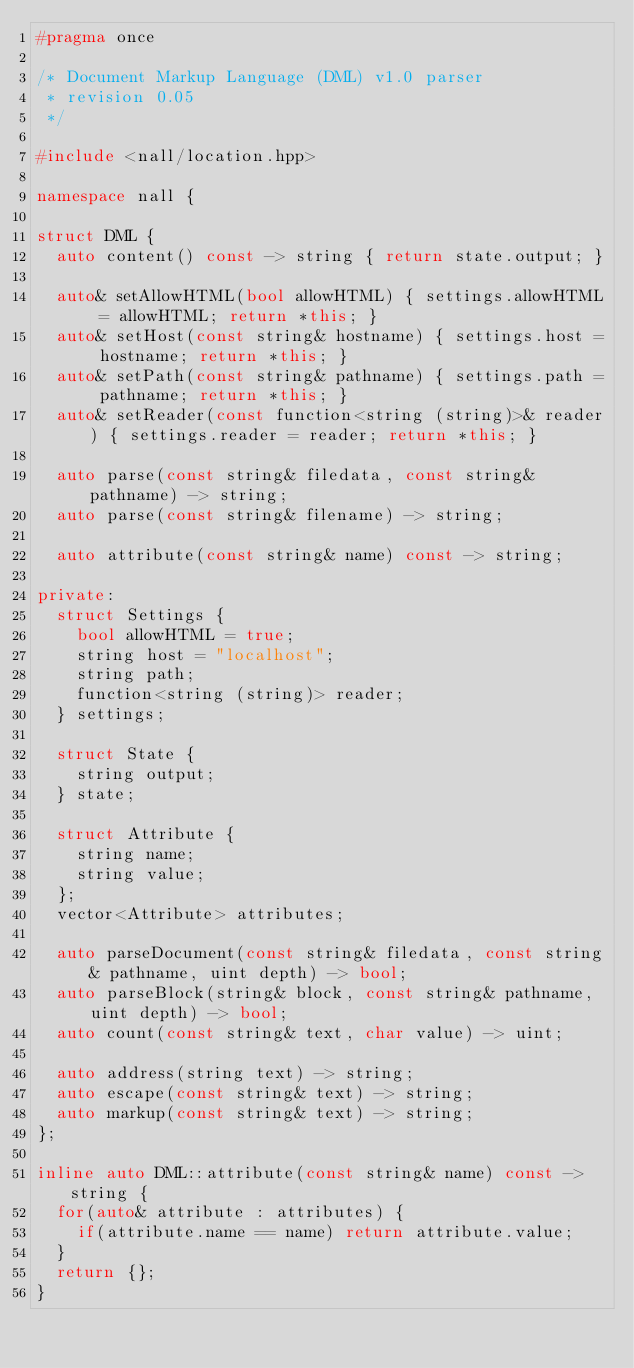Convert code to text. <code><loc_0><loc_0><loc_500><loc_500><_C++_>#pragma once

/* Document Markup Language (DML) v1.0 parser
 * revision 0.05
 */

#include <nall/location.hpp>

namespace nall {

struct DML {
  auto content() const -> string { return state.output; }

  auto& setAllowHTML(bool allowHTML) { settings.allowHTML = allowHTML; return *this; }
  auto& setHost(const string& hostname) { settings.host = hostname; return *this; }
  auto& setPath(const string& pathname) { settings.path = pathname; return *this; }
  auto& setReader(const function<string (string)>& reader) { settings.reader = reader; return *this; }

  auto parse(const string& filedata, const string& pathname) -> string;
  auto parse(const string& filename) -> string;

  auto attribute(const string& name) const -> string;

private:
  struct Settings {
    bool allowHTML = true;
    string host = "localhost";
    string path;
    function<string (string)> reader;
  } settings;

  struct State {
    string output;
  } state;

  struct Attribute {
    string name;
    string value;
  };
  vector<Attribute> attributes;

  auto parseDocument(const string& filedata, const string& pathname, uint depth) -> bool;
  auto parseBlock(string& block, const string& pathname, uint depth) -> bool;
  auto count(const string& text, char value) -> uint;

  auto address(string text) -> string;
  auto escape(const string& text) -> string;
  auto markup(const string& text) -> string;
};

inline auto DML::attribute(const string& name) const -> string {
  for(auto& attribute : attributes) {
    if(attribute.name == name) return attribute.value;
  }
  return {};
}
</code> 